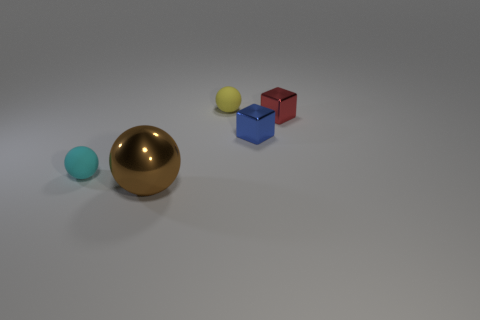What could be the purpose of arranging these objects in this manner? The arrangement of these objects could serve multiple purposes. It may be a visual exercise in composition and color, a demonstration of rendering techniques in 3D modeling software, or an artistic display meant to provoke thought about form and material contrast. 